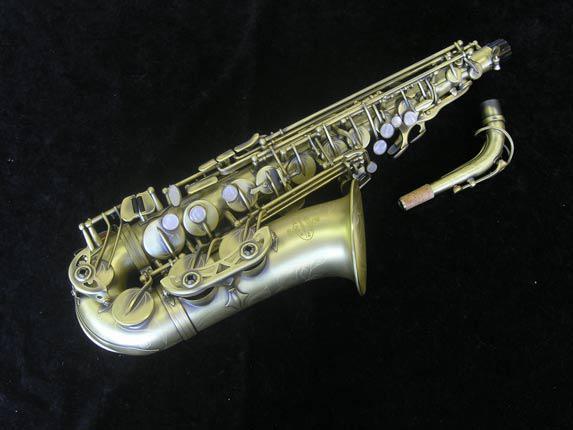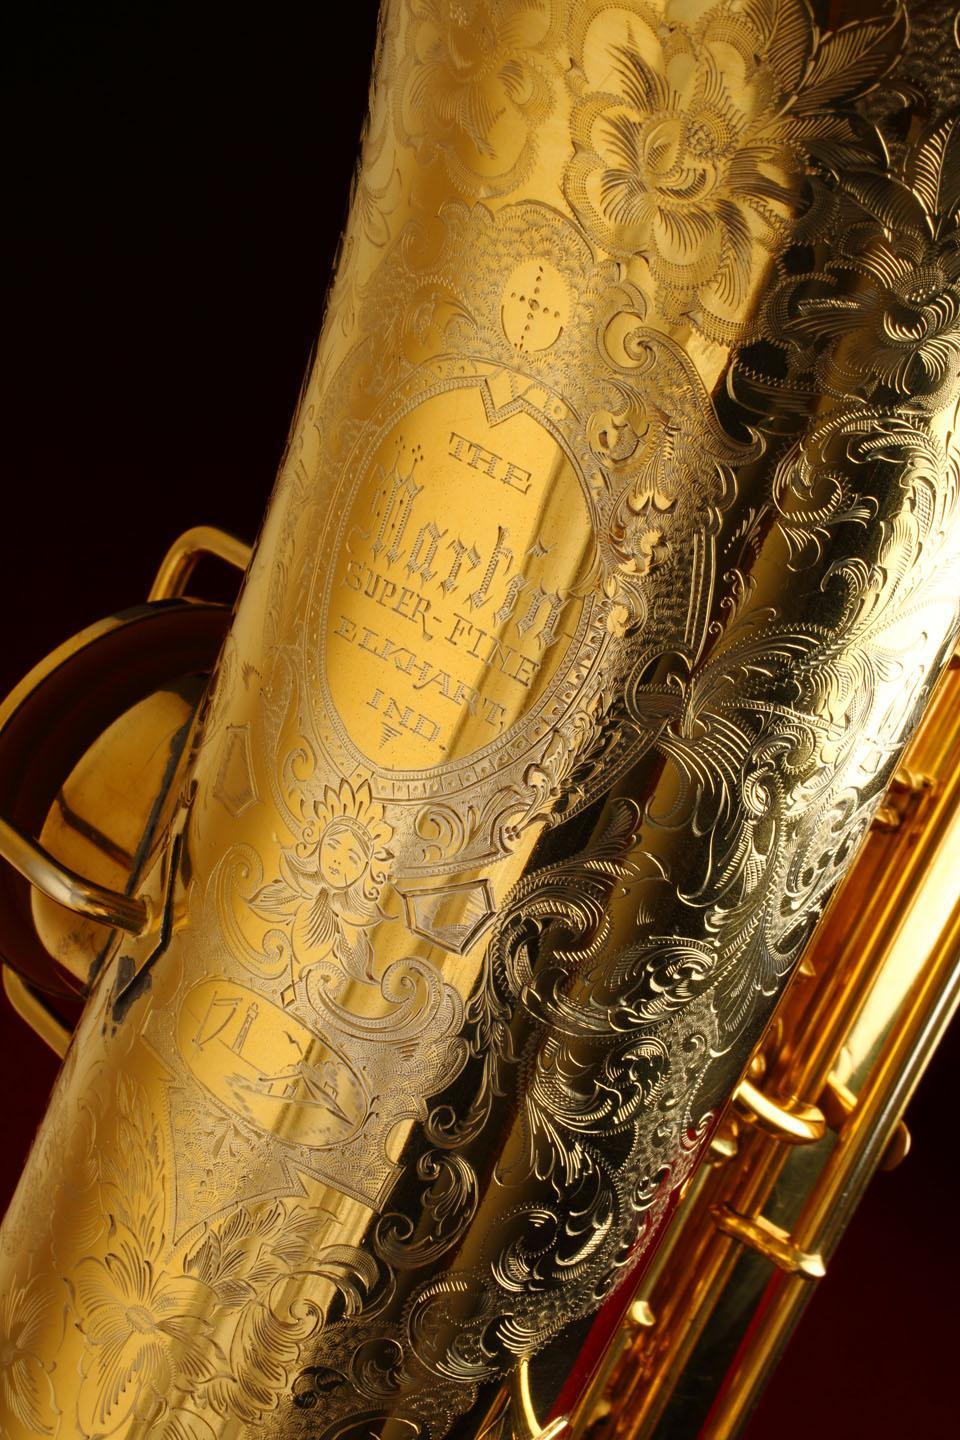The first image is the image on the left, the second image is the image on the right. Assess this claim about the two images: "In one image, a saxophone is shown in an upright position with the mouthpiece removed and placed beside it.". Correct or not? Answer yes or no. No. 